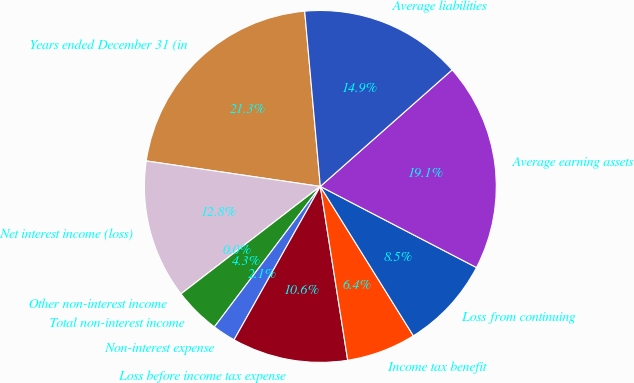Convert chart to OTSL. <chart><loc_0><loc_0><loc_500><loc_500><pie_chart><fcel>Years ended December 31 (in<fcel>Net interest income (loss)<fcel>Other non-interest income<fcel>Total non-interest income<fcel>Non-interest expense<fcel>Loss before income tax expense<fcel>Income tax benefit<fcel>Loss from continuing<fcel>Average earning assets<fcel>Average liabilities<nl><fcel>21.27%<fcel>12.77%<fcel>0.0%<fcel>4.26%<fcel>2.13%<fcel>10.64%<fcel>6.38%<fcel>8.51%<fcel>19.15%<fcel>14.89%<nl></chart> 